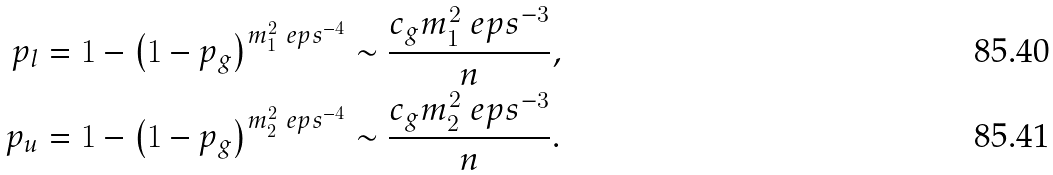Convert formula to latex. <formula><loc_0><loc_0><loc_500><loc_500>p _ { l } & = 1 - \left ( 1 - p _ { g } \right ) ^ { m _ { 1 } ^ { 2 } \ e p s ^ { - 4 } } \sim \frac { c _ { g } m _ { 1 } ^ { 2 } \ e p s ^ { - 3 } } { n } , \\ p _ { u } & = 1 - \left ( 1 - p _ { g } \right ) ^ { m _ { 2 } ^ { 2 } \ e p s ^ { - 4 } } \sim \frac { c _ { g } m _ { 2 } ^ { 2 } \ e p s ^ { - 3 } } { n } .</formula> 